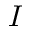Convert formula to latex. <formula><loc_0><loc_0><loc_500><loc_500>I</formula> 